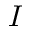Convert formula to latex. <formula><loc_0><loc_0><loc_500><loc_500>I</formula> 